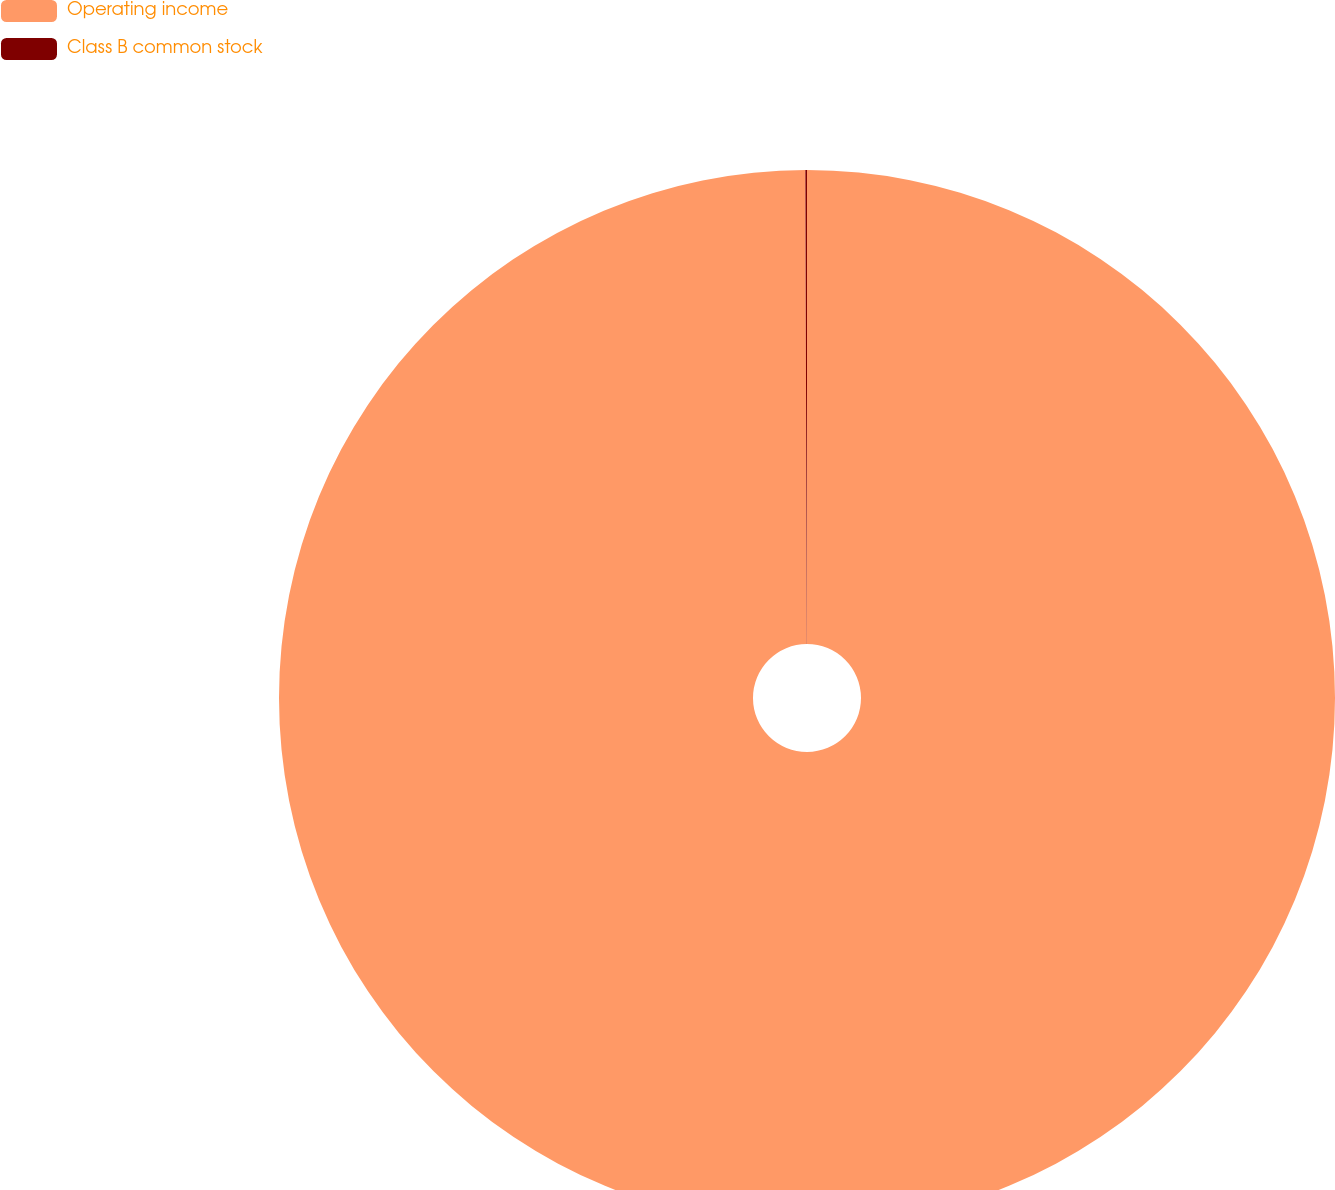<chart> <loc_0><loc_0><loc_500><loc_500><pie_chart><fcel>Operating income<fcel>Class B common stock<nl><fcel>99.95%<fcel>0.05%<nl></chart> 